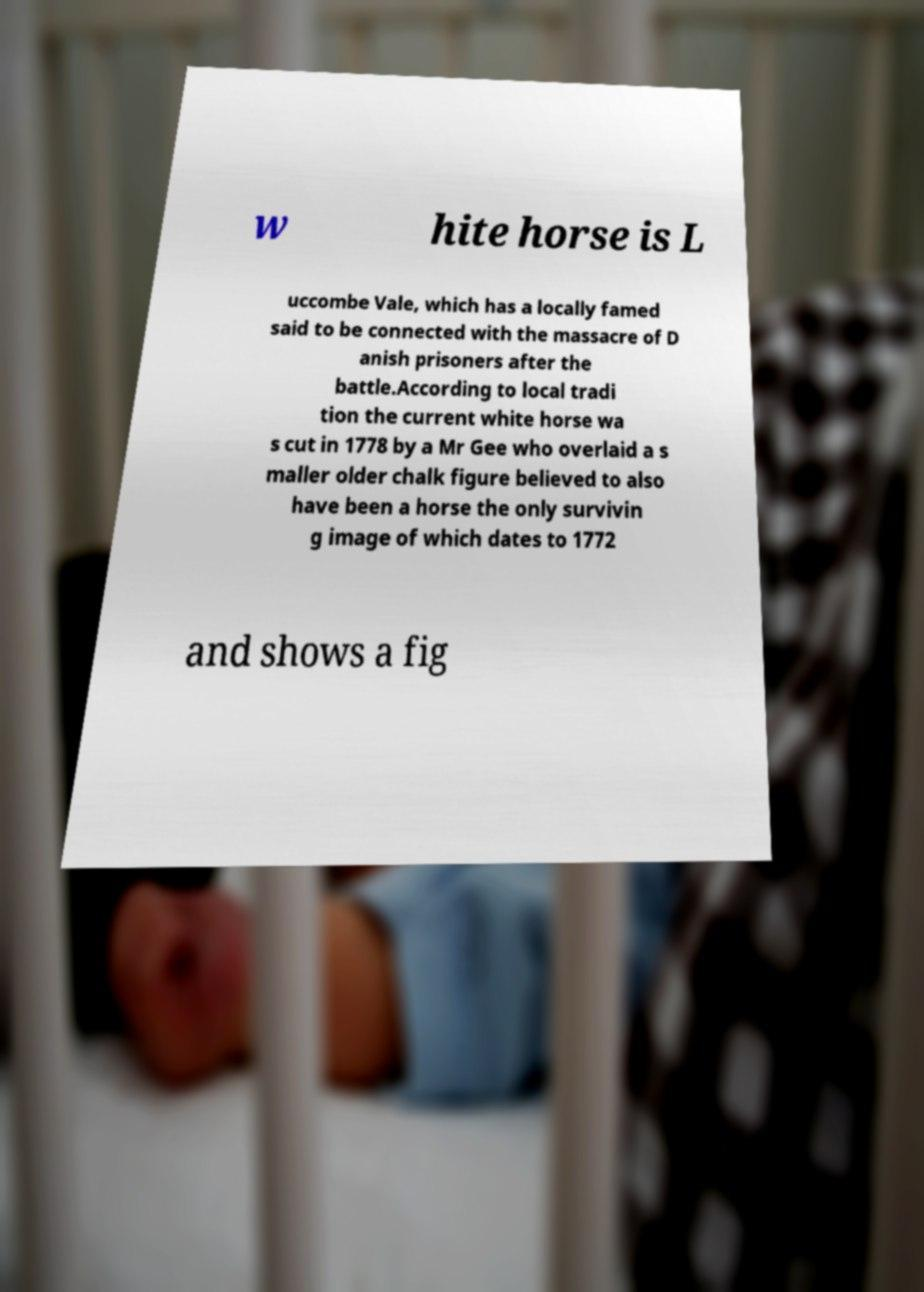What messages or text are displayed in this image? I need them in a readable, typed format. w hite horse is L uccombe Vale, which has a locally famed said to be connected with the massacre of D anish prisoners after the battle.According to local tradi tion the current white horse wa s cut in 1778 by a Mr Gee who overlaid a s maller older chalk figure believed to also have been a horse the only survivin g image of which dates to 1772 and shows a fig 